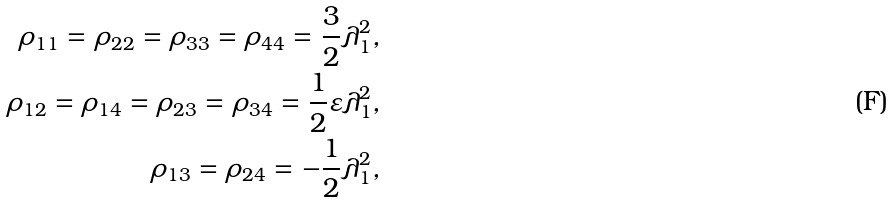<formula> <loc_0><loc_0><loc_500><loc_500>\rho _ { 1 1 } = \rho _ { 2 2 } = \rho _ { 3 3 } = \rho _ { 4 4 } = \frac { 3 } { 2 } \lambda _ { 1 } ^ { 2 } , \\ \rho _ { 1 2 } = \rho _ { 1 4 } = \rho _ { 2 3 } = \rho _ { 3 4 } = \frac { 1 } { 2 } \varepsilon \lambda _ { 1 } ^ { 2 } , \\ \rho _ { 1 3 } = \rho _ { 2 4 } = - \frac { 1 } { 2 } \lambda _ { 1 } ^ { 2 } ,</formula> 